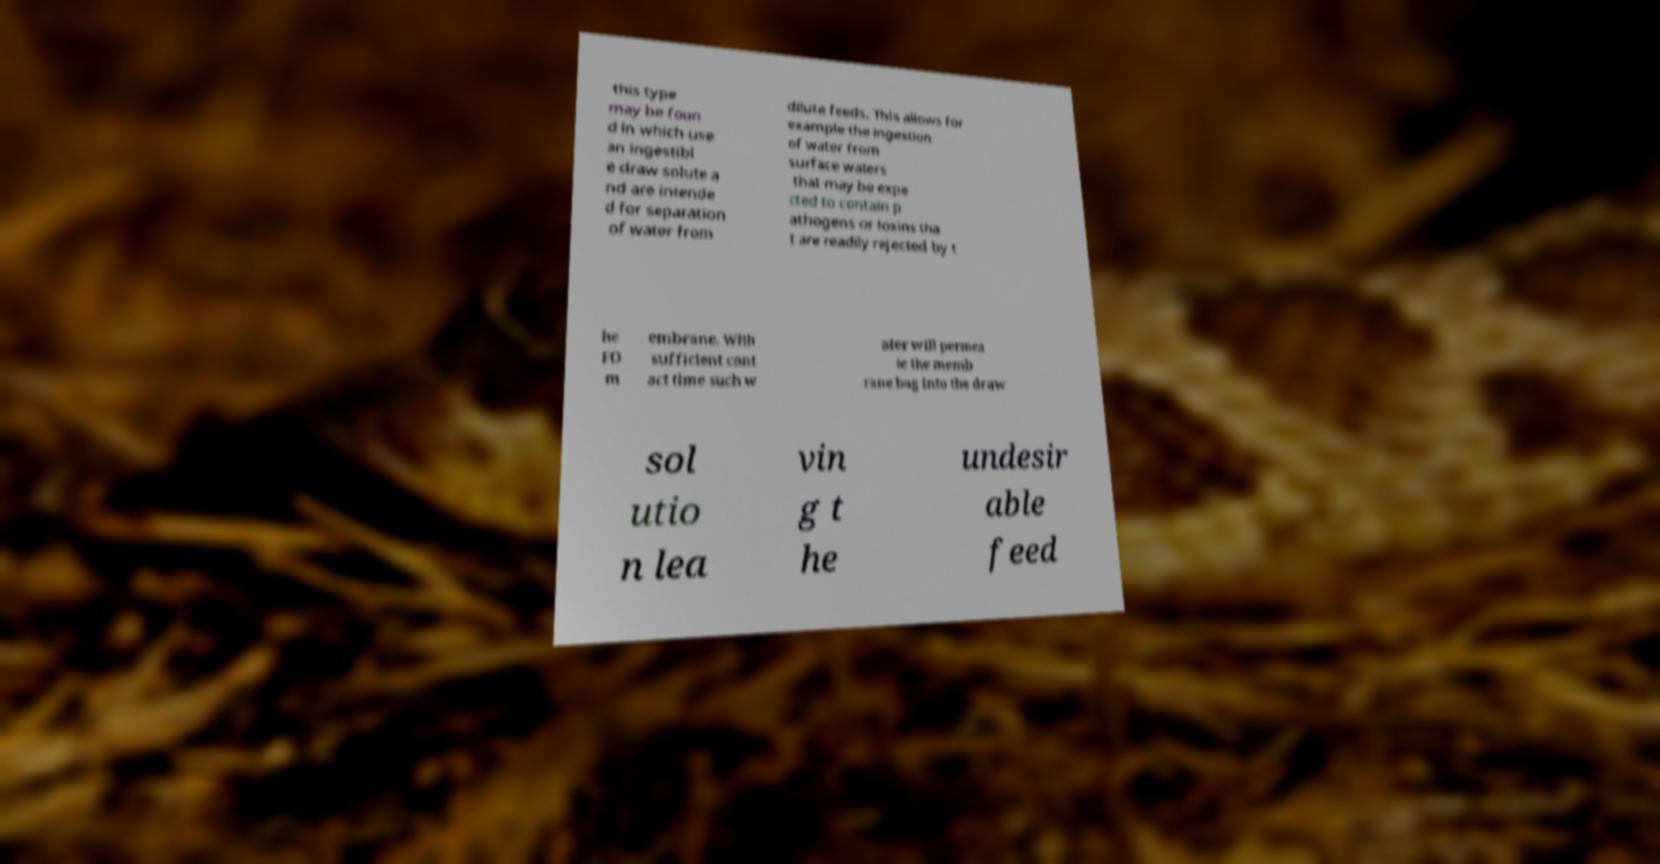Can you accurately transcribe the text from the provided image for me? this type may be foun d in which use an ingestibl e draw solute a nd are intende d for separation of water from dilute feeds. This allows for example the ingestion of water from surface waters that may be expe cted to contain p athogens or toxins tha t are readily rejected by t he FO m embrane. With sufficient cont act time such w ater will permea te the memb rane bag into the draw sol utio n lea vin g t he undesir able feed 